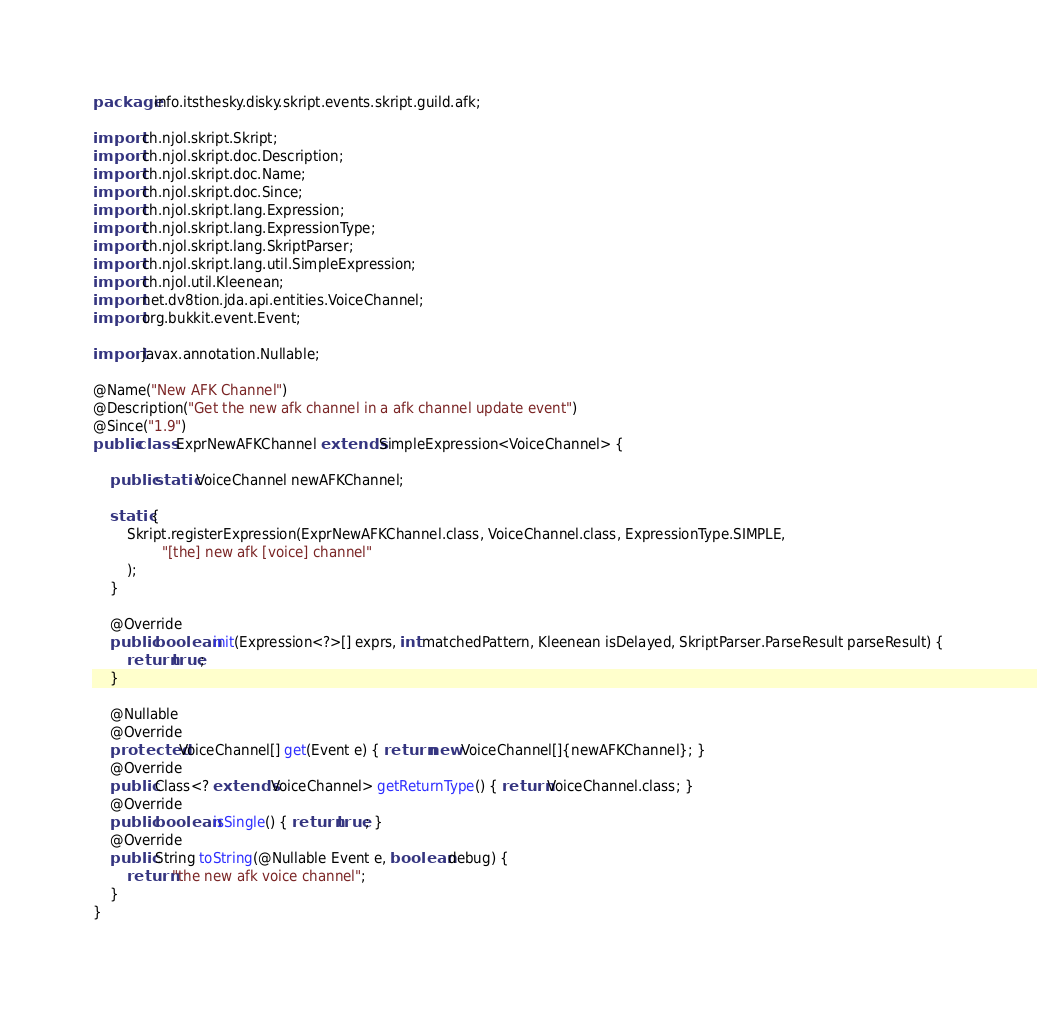<code> <loc_0><loc_0><loc_500><loc_500><_Java_>package info.itsthesky.disky.skript.events.skript.guild.afk;

import ch.njol.skript.Skript;
import ch.njol.skript.doc.Description;
import ch.njol.skript.doc.Name;
import ch.njol.skript.doc.Since;
import ch.njol.skript.lang.Expression;
import ch.njol.skript.lang.ExpressionType;
import ch.njol.skript.lang.SkriptParser;
import ch.njol.skript.lang.util.SimpleExpression;
import ch.njol.util.Kleenean;
import net.dv8tion.jda.api.entities.VoiceChannel;
import org.bukkit.event.Event;

import javax.annotation.Nullable;

@Name("New AFK Channel")
@Description("Get the new afk channel in a afk channel update event")
@Since("1.9")
public class ExprNewAFKChannel extends SimpleExpression<VoiceChannel> {

    public static VoiceChannel newAFKChannel;

    static {
        Skript.registerExpression(ExprNewAFKChannel.class, VoiceChannel.class, ExpressionType.SIMPLE,
                "[the] new afk [voice] channel"
        );
    }

    @Override
    public boolean init(Expression<?>[] exprs, int matchedPattern, Kleenean isDelayed, SkriptParser.ParseResult parseResult) {
        return true;
    }

    @Nullable
    @Override
    protected VoiceChannel[] get(Event e) { return new VoiceChannel[]{newAFKChannel}; }
    @Override
    public Class<? extends VoiceChannel> getReturnType() { return VoiceChannel.class; }
    @Override
    public boolean isSingle() { return true; }
    @Override
    public String toString(@Nullable Event e, boolean debug) {
        return "the new afk voice channel";
    }
}
</code> 